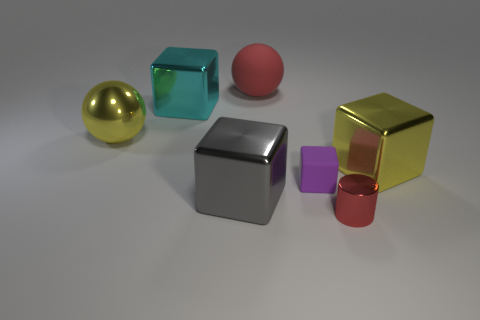Are there any other things that have the same shape as the red metal object?
Your response must be concise. No. There is a small thing that is left of the red object in front of the tiny purple rubber object; what shape is it?
Make the answer very short. Cube. What is the shape of the big gray thing that is the same material as the tiny red cylinder?
Make the answer very short. Cube. There is a sphere to the left of the matte thing behind the large shiny ball; what is its size?
Ensure brevity in your answer.  Large. What is the shape of the big gray shiny object?
Provide a short and direct response. Cube. What number of tiny objects are either yellow shiny spheres or gray cubes?
Offer a very short reply. 0. What is the size of the other yellow object that is the same shape as the big rubber thing?
Give a very brief answer. Large. What number of things are both behind the purple matte cube and to the left of the yellow shiny cube?
Your answer should be very brief. 3. Is the shape of the tiny metal object the same as the big shiny thing on the right side of the red metallic cylinder?
Keep it short and to the point. No. Are there more large shiny balls in front of the purple object than small red shiny cylinders?
Provide a short and direct response. No. 